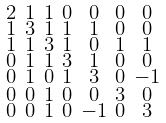<formula> <loc_0><loc_0><loc_500><loc_500>\begin{smallmatrix} 2 & 1 & 1 & 0 & 0 & 0 & 0 \\ 1 & 3 & 1 & 1 & 1 & 0 & 0 \\ 1 & 1 & 3 & 1 & 0 & 1 & 1 \\ 0 & 1 & 1 & 3 & 1 & 0 & 0 \\ 0 & 1 & 0 & 1 & 3 & 0 & - 1 \\ 0 & 0 & 1 & 0 & 0 & 3 & 0 \\ 0 & 0 & 1 & 0 & - 1 & 0 & 3 \end{smallmatrix}</formula> 